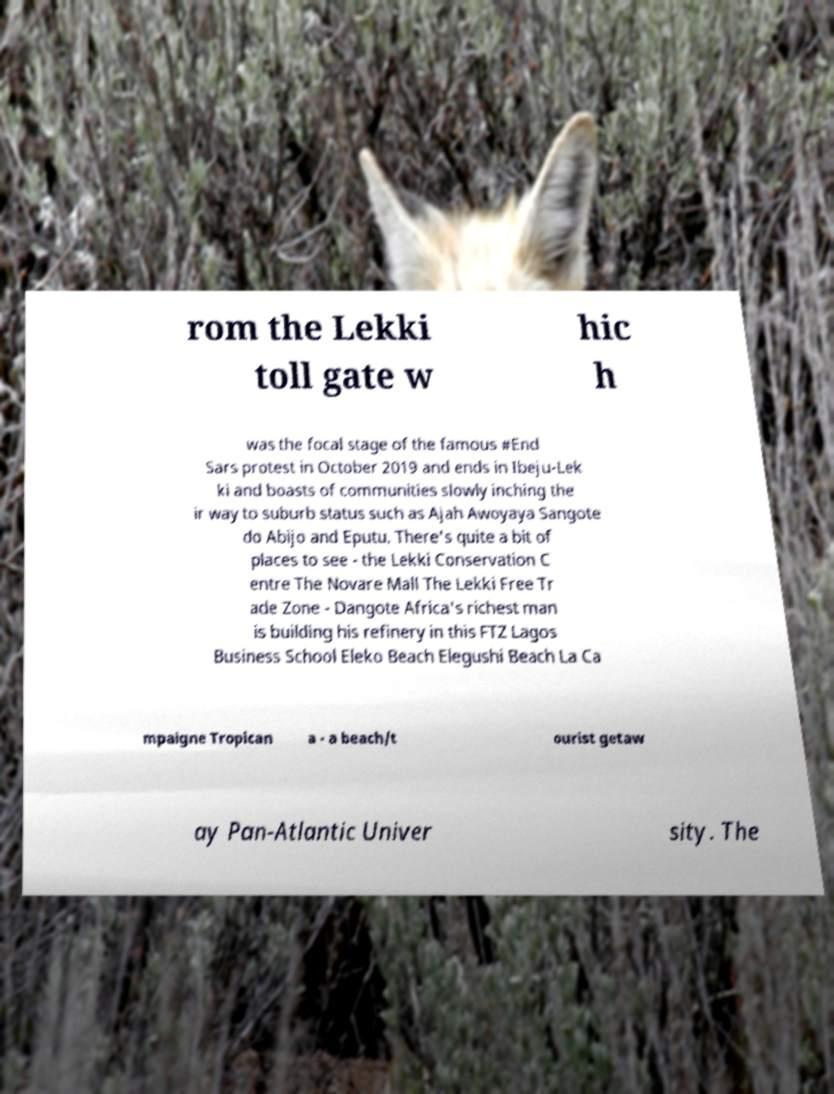What messages or text are displayed in this image? I need them in a readable, typed format. rom the Lekki toll gate w hic h was the focal stage of the famous #End Sars protest in October 2019 and ends in Ibeju-Lek ki and boasts of communities slowly inching the ir way to suburb status such as Ajah Awoyaya Sangote do Abijo and Eputu. There's quite a bit of places to see - the Lekki Conservation C entre The Novare Mall The Lekki Free Tr ade Zone - Dangote Africa's richest man is building his refinery in this FTZ Lagos Business School Eleko Beach Elegushi Beach La Ca mpaigne Tropican a - a beach/t ourist getaw ay Pan-Atlantic Univer sity. The 